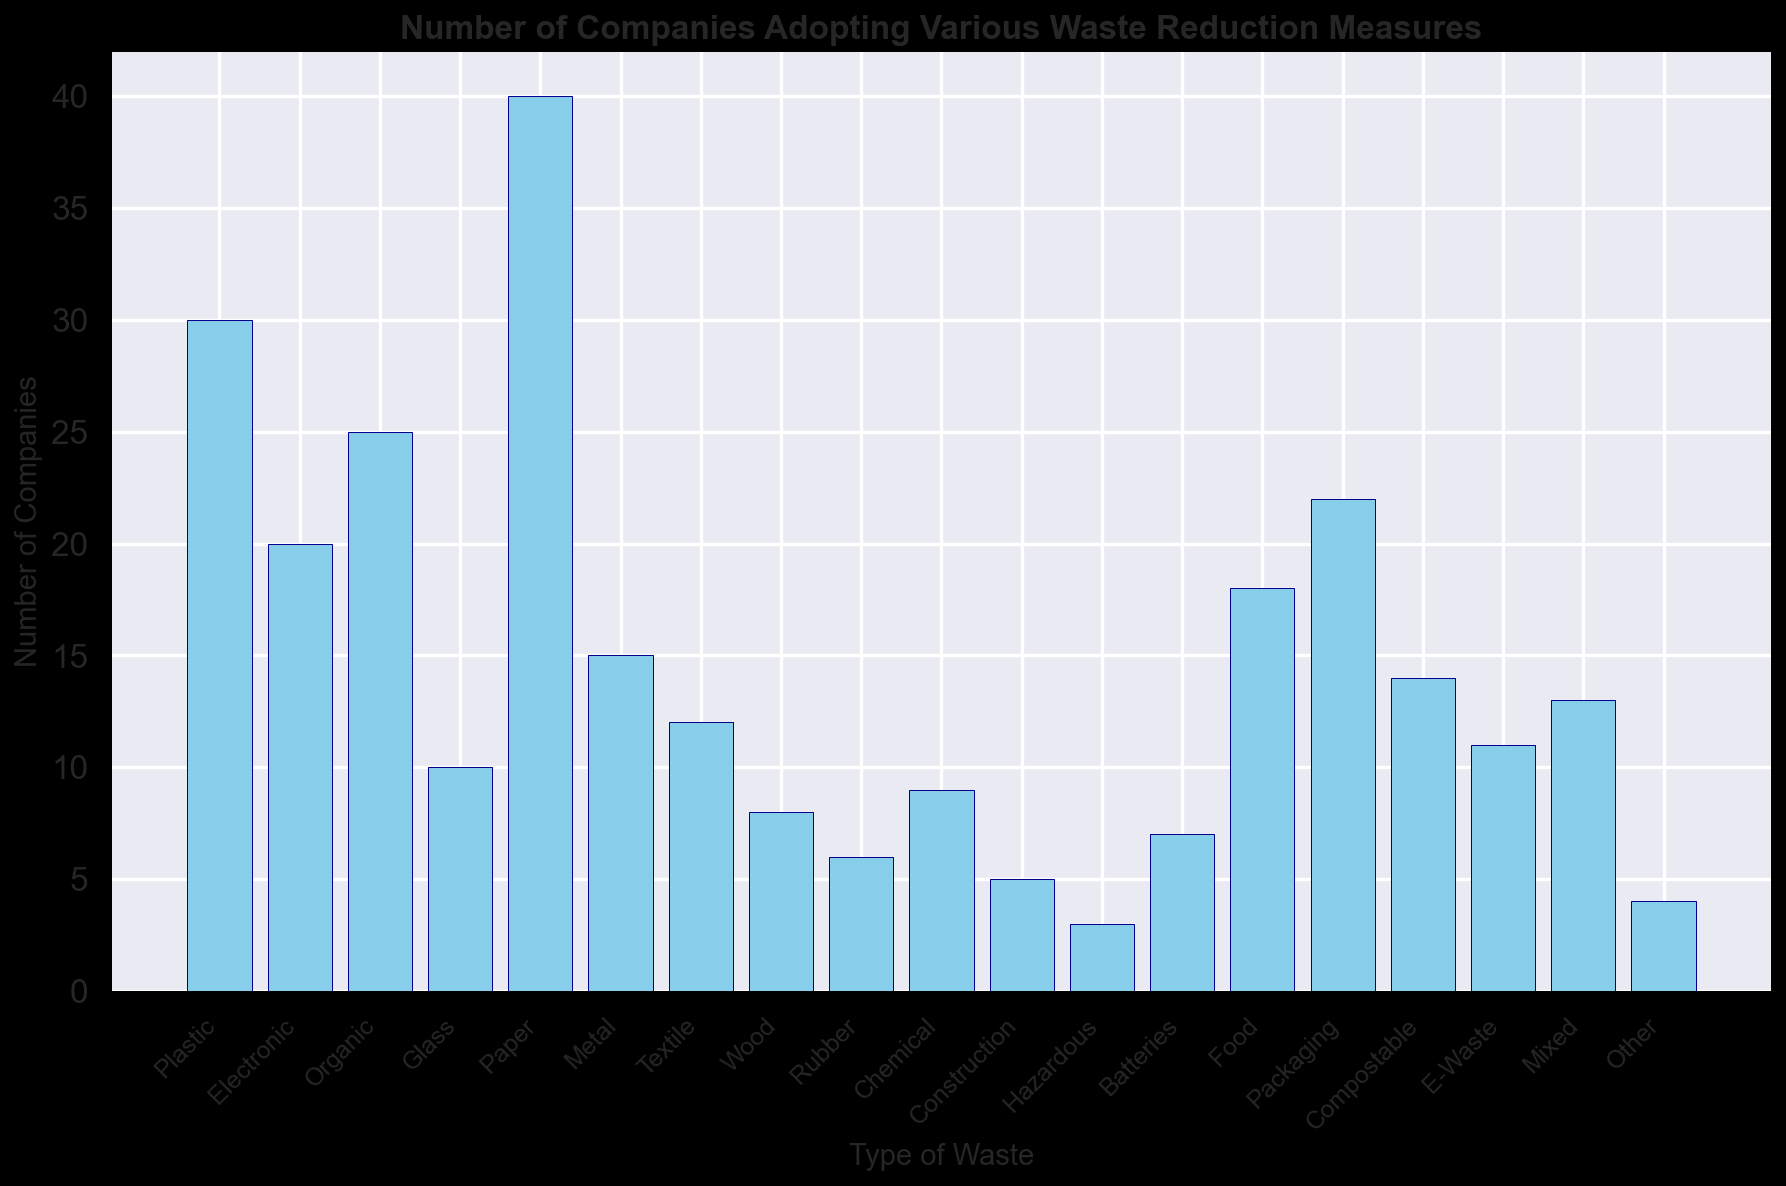Which type of waste has the highest number of companies adopting waste reduction measures? Looking at the height of the bars in the histogram, the bar representing 'Paper' is the tallest. This indicates that Paper has the highest number of companies adopting waste reduction measures.
Answer: Paper Which type of waste had fewer companies adopting waste reduction measures, Chemicals or Wood? Comparing the height of the bars for Chemicals and Wood, the bar for Wood is shorter than the bar for Chemicals. Therefore, fewer companies adopted waste reduction measures for Wood.
Answer: Wood What is the total number of companies that adopted waste reduction measures for Hazardous and Mixed waste combined? Looking at the counts on the bar plot, the number of companies for Hazardous waste is 3 and for Mixed waste is 13. Adding them together gives 3 + 13 = 16.
Answer: 16 Which type of waste reduction has exactly ten companies adopting the measures? Among the bars, 'Glass' has a bar height that corresponds to 10 companies, which is exactly ten.
Answer: Glass By how many companies does the adoption of waste reduction measures for Plastic exceed those for Electronic waste? From the bar height, the number of companies for Plastic is 30 and for Electronic is 20. The difference is 30 - 20 = 10.
Answer: 10 Is the number of companies adopting waste reduction for Packaging greater than, less than, or equal to the number of companies adopting waste reduction for Food waste? By comparing the heights of the two bars, the 'Packaging' bar (22) is taller than the 'Food' bar (18), implying there are more companies adopting waste reduction for Packaging.
Answer: greater than What is the average number of companies adopting waste reduction measures for Batteries, Food, and Compostable waste? The bars for Batteries, Food, and Compostable show 7, 18, and 14 companies respectively. The average is calculated as (7 + 18 + 14) / 3 = 39 / 3 = 13.
Answer: 13 How many types of waste have fewer than 10 companies adopting waste reduction measures? From the histogram, the types of waste with fewer than 10 companies are Wood (8), Rubber (6), Chemical (9), Construction (5), Hazardous (3), Batteries (7), and Other (4). There are 7 types in total.
Answer: 7 What's the combined total number of companies adopting waste reduction measures for Organic and Compostable waste? The bars show 25 companies for Organic and 14 for Compostable. Adding them gives 25 + 14 = 39.
Answer: 39 